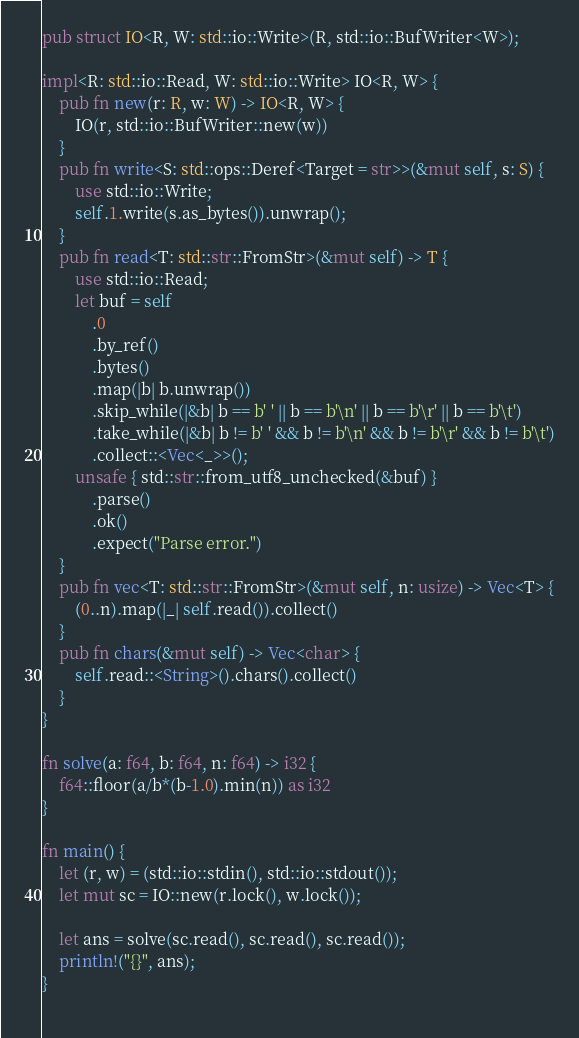<code> <loc_0><loc_0><loc_500><loc_500><_Rust_>pub struct IO<R, W: std::io::Write>(R, std::io::BufWriter<W>);
 
impl<R: std::io::Read, W: std::io::Write> IO<R, W> {
    pub fn new(r: R, w: W) -> IO<R, W> {
        IO(r, std::io::BufWriter::new(w))
    }
    pub fn write<S: std::ops::Deref<Target = str>>(&mut self, s: S) {
        use std::io::Write;
        self.1.write(s.as_bytes()).unwrap();
    }
    pub fn read<T: std::str::FromStr>(&mut self) -> T {
        use std::io::Read;
        let buf = self
            .0
            .by_ref()
            .bytes()
            .map(|b| b.unwrap())
            .skip_while(|&b| b == b' ' || b == b'\n' || b == b'\r' || b == b'\t')
            .take_while(|&b| b != b' ' && b != b'\n' && b != b'\r' && b != b'\t')
            .collect::<Vec<_>>();
        unsafe { std::str::from_utf8_unchecked(&buf) }
            .parse()
            .ok()
            .expect("Parse error.")
    }
    pub fn vec<T: std::str::FromStr>(&mut self, n: usize) -> Vec<T> {
        (0..n).map(|_| self.read()).collect()
    }
    pub fn chars(&mut self) -> Vec<char> {
        self.read::<String>().chars().collect()
    }
}

fn solve(a: f64, b: f64, n: f64) -> i32 {
    f64::floor(a/b*(b-1.0).min(n)) as i32
}

fn main() {
    let (r, w) = (std::io::stdin(), std::io::stdout());
    let mut sc = IO::new(r.lock(), w.lock());

    let ans = solve(sc.read(), sc.read(), sc.read());
    println!("{}", ans);
}
 
</code> 